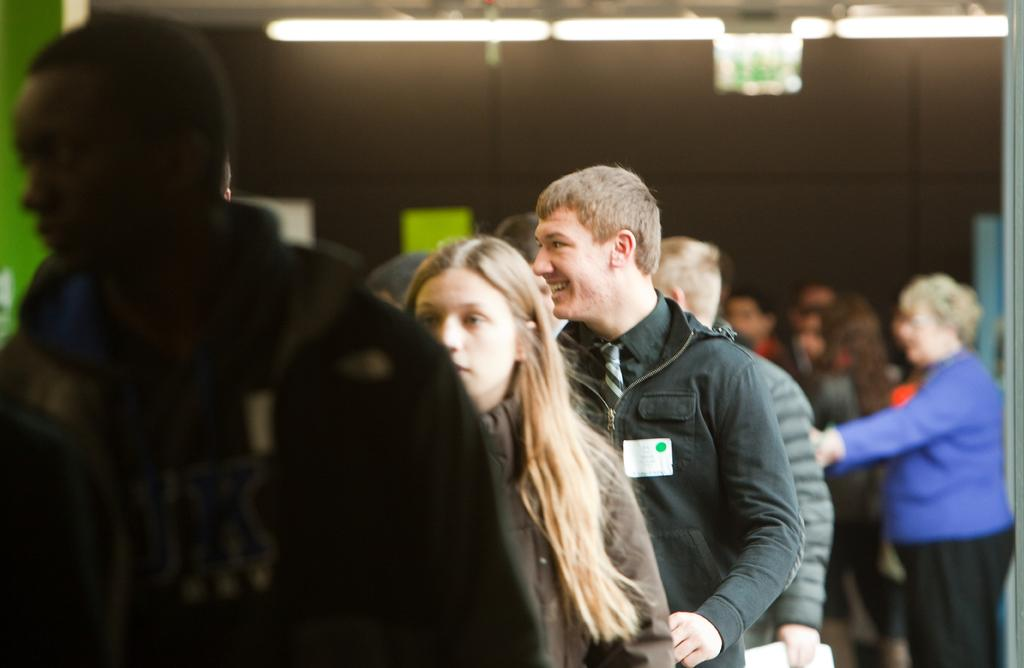What is happening in the foreground of the image? There are people standing in the foreground of the image. What can be seen in the background of the image? There are lamps in the background of the image. What type of house is located in the middle of the image? There is no house present in the image; it only features people in the foreground and lamps in the background. 